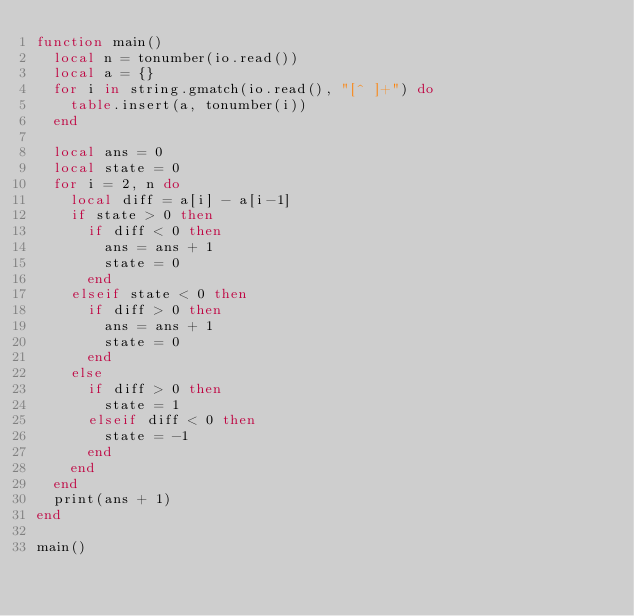<code> <loc_0><loc_0><loc_500><loc_500><_Lua_>function main()
  local n = tonumber(io.read())
  local a = {}
  for i in string.gmatch(io.read(), "[^ ]+") do
    table.insert(a, tonumber(i))
  end

  local ans = 0
  local state = 0
  for i = 2, n do
    local diff = a[i] - a[i-1]
    if state > 0 then
      if diff < 0 then
        ans = ans + 1
        state = 0
      end
    elseif state < 0 then
      if diff > 0 then
        ans = ans + 1
        state = 0
      end
    else
      if diff > 0 then
        state = 1
      elseif diff < 0 then
        state = -1
      end
    end
  end
  print(ans + 1)
end

main()
</code> 